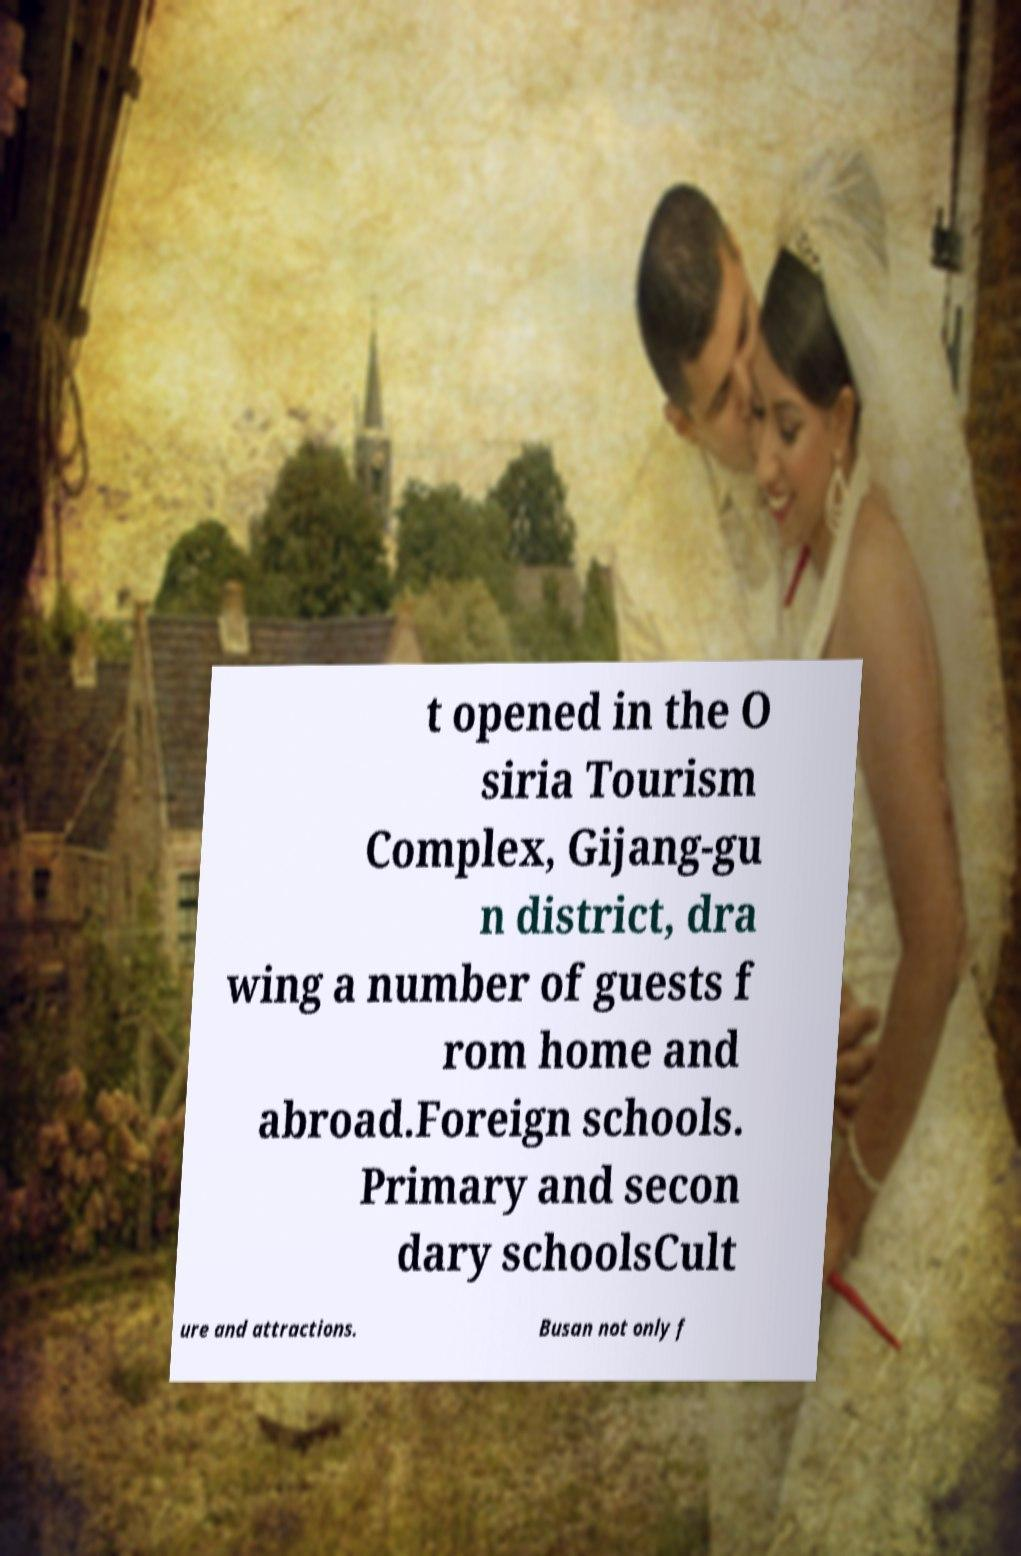For documentation purposes, I need the text within this image transcribed. Could you provide that? t opened in the O siria Tourism Complex, Gijang-gu n district, dra wing a number of guests f rom home and abroad.Foreign schools. Primary and secon dary schoolsCult ure and attractions. Busan not only f 